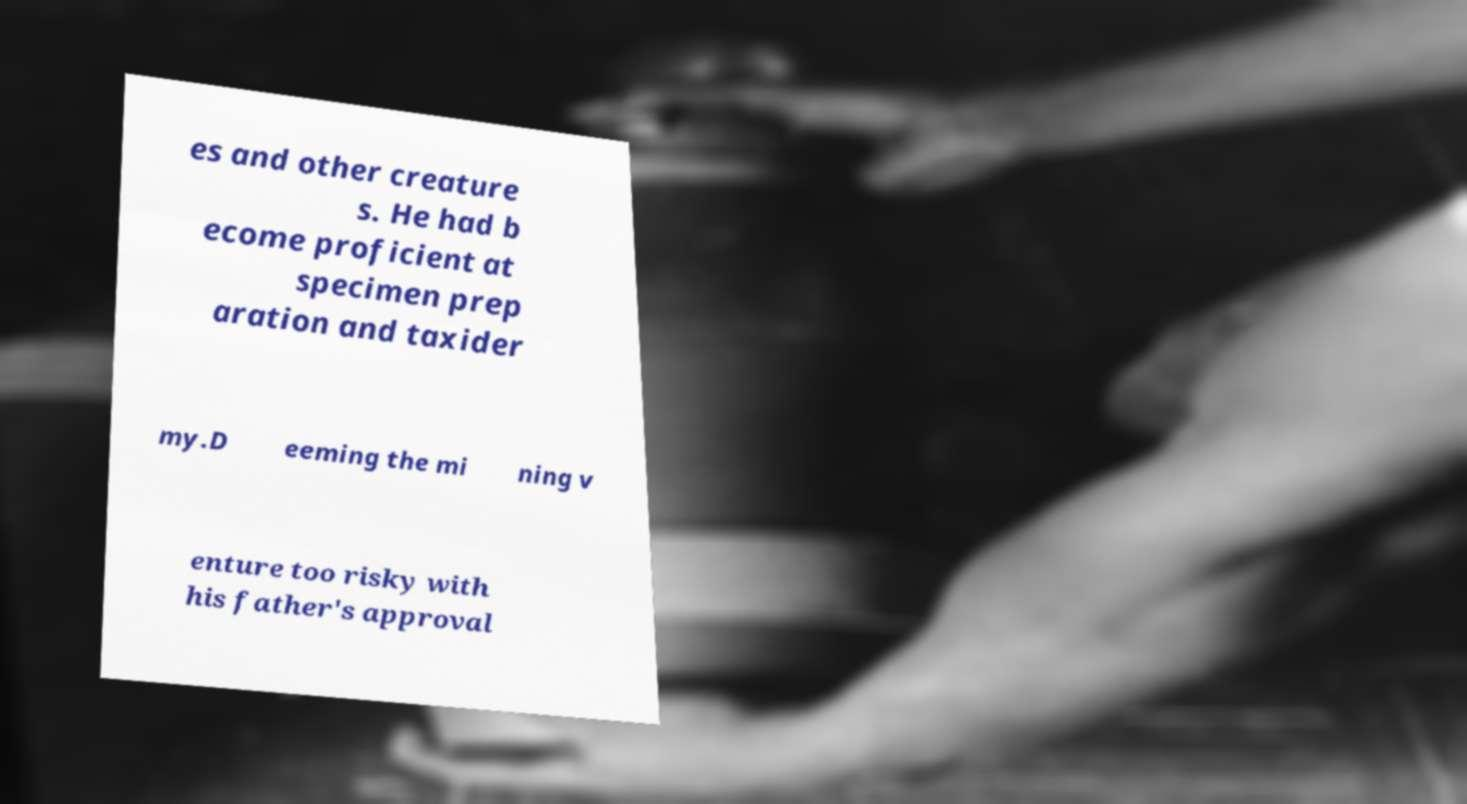I need the written content from this picture converted into text. Can you do that? es and other creature s. He had b ecome proficient at specimen prep aration and taxider my.D eeming the mi ning v enture too risky with his father's approval 